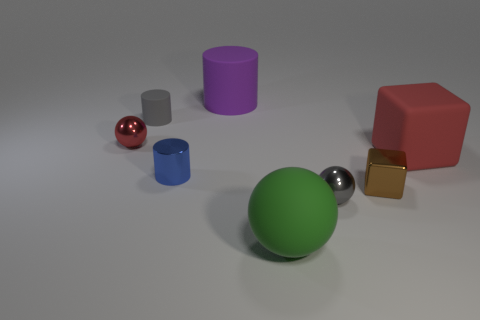What shape is the metal thing that is the same color as the big rubber block?
Your response must be concise. Sphere. There is a metal sphere that is the same color as the large cube; what size is it?
Your answer should be compact. Small. What is the gray thing in front of the matte thing that is on the right side of the metal sphere that is to the right of the purple cylinder made of?
Offer a very short reply. Metal. How many purple objects are there?
Offer a terse response. 1. How many blue things are tiny cylinders or tiny metallic balls?
Your answer should be very brief. 1. How many other things are there of the same shape as the tiny red thing?
Provide a short and direct response. 2. Is the color of the tiny object that is on the left side of the tiny rubber cylinder the same as the big object that is right of the large matte ball?
Keep it short and to the point. Yes. What number of large things are gray cylinders or spheres?
Give a very brief answer. 1. There is another matte object that is the same shape as the brown object; what is its size?
Provide a succinct answer. Large. Is there anything else that is the same size as the matte sphere?
Provide a short and direct response. Yes. 